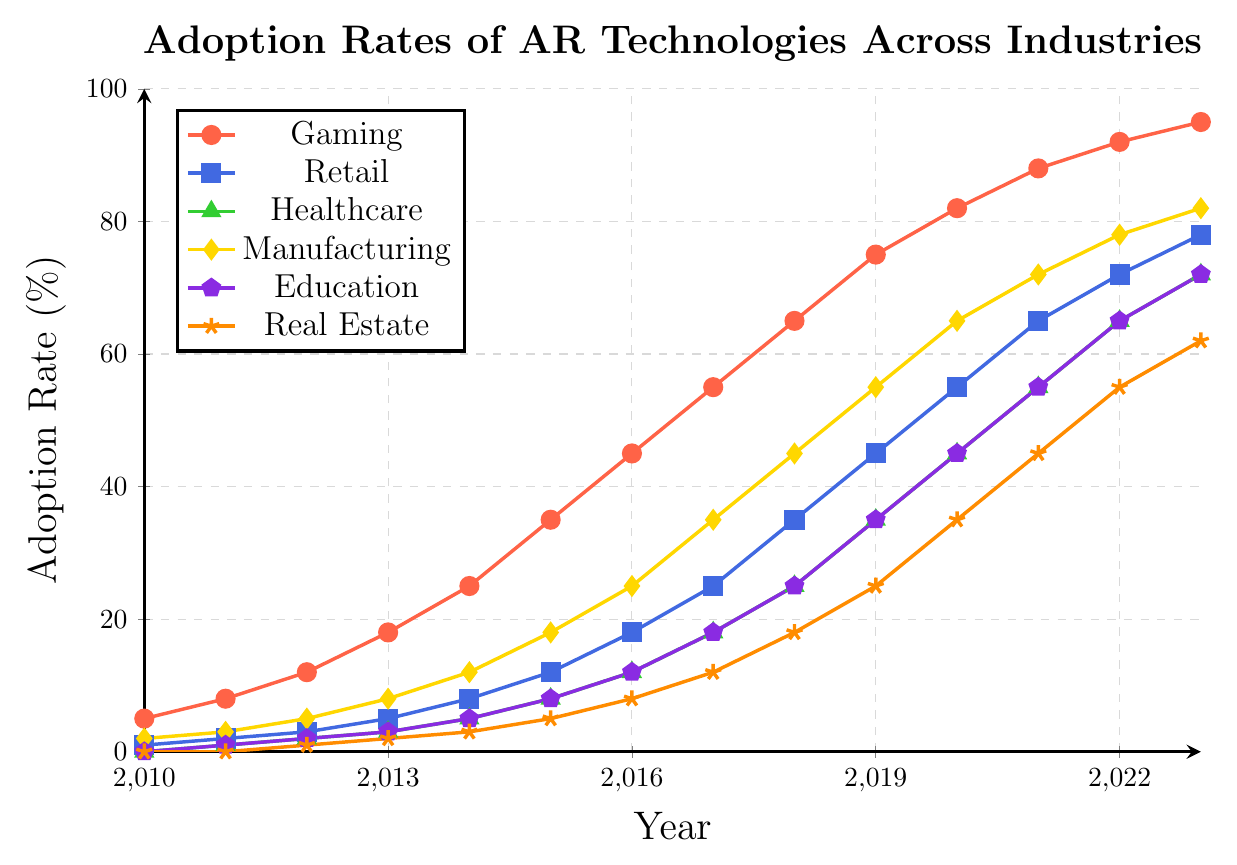Which industry had the highest adoption rate of AR technologies in 2023? By examining the end of the lines in the figure and noting their corresponding years, we see that the "Gaming" industry has the highest line end value at 95 in 2023 compared to other industries.
Answer: Gaming How did the adoption rate of AR technologies in the Healthcare industry change from 2010 to 2023? By looking at the “Healthcare” line in the figure from 2010 to 2023, we see that it starts at 0 in 2010 and rises to 72 in 2023. The change is the difference between these values: 72 - 0 = 72.
Answer: 72 By looking at the figure, which industry experienced the fastest growth in AR technology adoption from 2010 to 2013? By comparing the slopes of the lines for each industry between 2010 and 2013, we see that the Gaming industry has the steepest slope, indicating the fastest growth. The adoption rate grew from 5 to 18, a difference of 13 in three years.
Answer: Gaming What is the difference in AR technology adoption rates between the Education and Real Estate industries in 2023? By looking at the endpoints of the "Education" and "Real Estate" lines in 2023, we see that Education is at 72 and Real Estate is at 62. The difference is 72 - 62 = 10.
Answer: 10 Which two industries had the same adoption rate in 2017, and what was that rate? By observing the figure, we can see that in 2017 both the "Healthcare" and "Education" industries reach 18%.
Answer: Healthcare and Education, 18% In which year did the Manufacturing industry's adoption rate of AR technologies exceed 50%? By following the "Manufacturing" line on the figure, we note that it surpasses the 50% mark between 2018 and 2019, specifically hitting 55% in 2019.
Answer: 2019 How did the adoption rate of AR technologies in Retail change from 2015 to 2020? By looking at the “Retail” line from 2015 to 2020, we see it increases from 12 in 2015 to 55 in 2020. The change is the difference between these values: 55 - 12 = 43.
Answer: 43 Between 2010 and 2023, did any industry show a linear growth pattern in AR technology adoption? Observing the figure, the "Retail" industry shows a relatively consistent linear growth pattern throughout the entire period, increasing by approximately equal amounts each year.
Answer: Retail What is the average adoption rate of AR technologies in Gaming from 2010 to 2023? Summing the values for Gaming from 2010 to 2023: 5 + 8 + 12 + 18 + 25 + 35 + 45 + 55 + 65 + 75 + 82 + 88 + 92 + 95 = 700, then dividing by the number of years (14), we get 700 / 14 = 50.
Answer: 50 Compare the growth rate of AR technology adoption in the Manufacturing and Real Estate industries between 2015 and 2020. Which one showed higher growth? From 2015 to 2020, the Manufacturing industry's adoption rate grew from 18 to 65 (an increase of 47), whereas the Real Estate industry's adoption rate grew from 5 to 35 (an increase of 30).
Answer: Manufacturing 